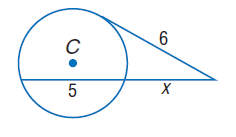Question: Find x. Assume that segments that appear to be tangent are tangent.
Choices:
A. 4
B. 6
C. 8
D. 10
Answer with the letter. Answer: A 